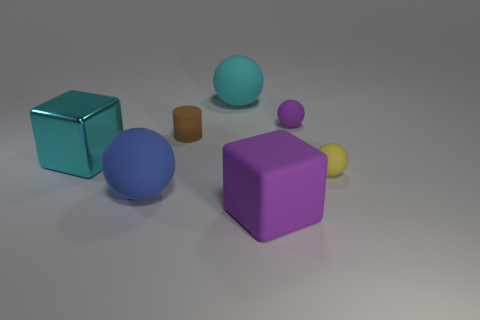Is there anything else that is the same material as the big cyan block?
Your response must be concise. No. What is the blue ball that is left of the brown matte object made of?
Keep it short and to the point. Rubber. Does the brown matte thing in front of the purple matte sphere have the same size as the purple rubber thing behind the blue sphere?
Provide a succinct answer. Yes. Is there another ball made of the same material as the yellow ball?
Make the answer very short. Yes. What shape is the yellow object?
Your answer should be very brief. Sphere. What shape is the large object in front of the large rubber sphere in front of the small brown matte cylinder?
Keep it short and to the point. Cube. How many other things are there of the same shape as the yellow thing?
Make the answer very short. 3. There is a thing to the left of the large rubber sphere to the left of the cyan ball; how big is it?
Offer a very short reply. Large. Are there any small yellow balls?
Keep it short and to the point. Yes. What number of objects are on the left side of the small thing behind the brown rubber cylinder?
Ensure brevity in your answer.  5. 